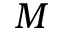Convert formula to latex. <formula><loc_0><loc_0><loc_500><loc_500>M</formula> 